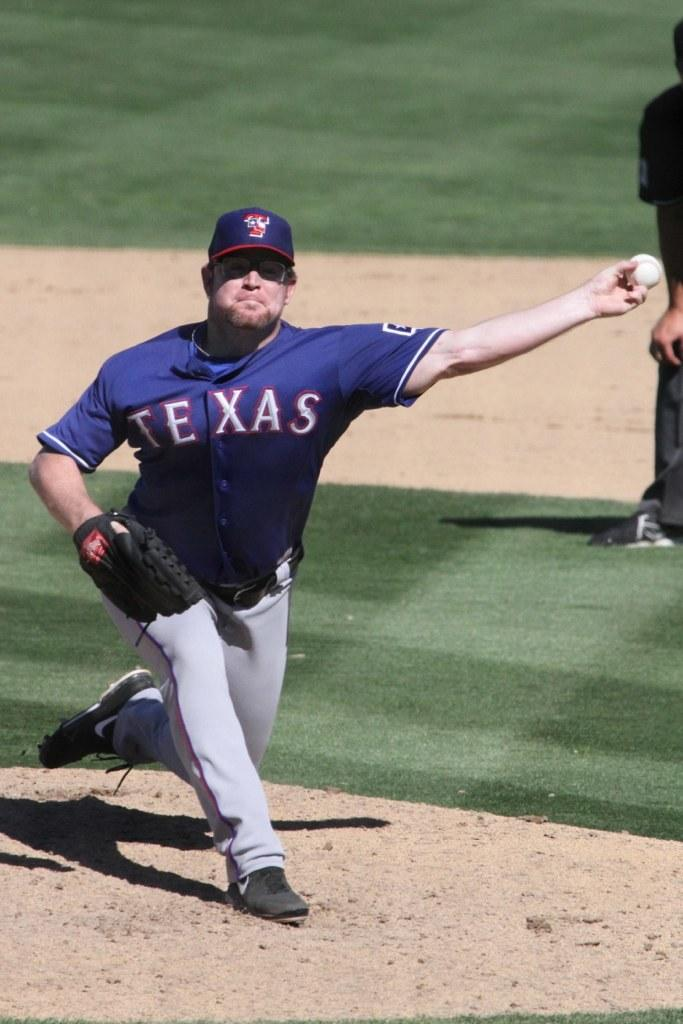<image>
Give a short and clear explanation of the subsequent image. A pitcher for a Texas team throwing a baseball. 